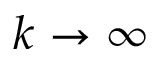<formula> <loc_0><loc_0><loc_500><loc_500>k \rightarrow \infty</formula> 